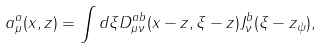Convert formula to latex. <formula><loc_0><loc_0><loc_500><loc_500>a ^ { a } _ { \mu } ( x , z ) = \int d \xi D ^ { a b } _ { \mu \nu } ( x - z , \xi - z ) J ^ { b } _ { \nu } ( \xi - z _ { \psi } ) ,</formula> 